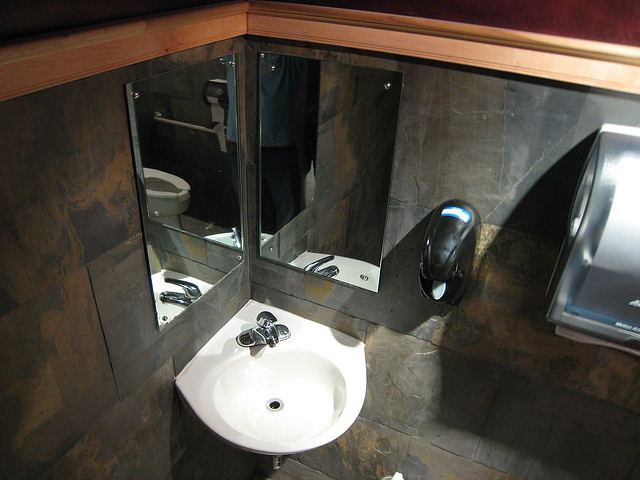Describe the objects in this image and their specific colors. I can see sink in black, white, darkgray, and gray tones, people in black, purple, gray, and darkblue tones, and toilet in black, gray, and darkgreen tones in this image. 